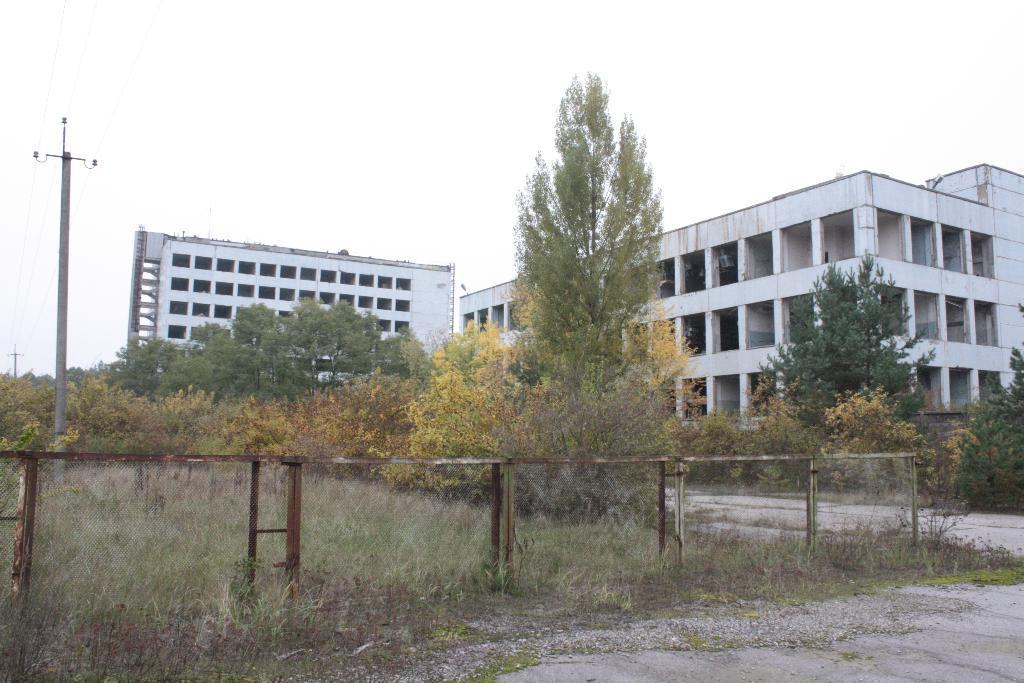Could you give a brief overview of what you see in this image? This image consists of grass, plants, fence, light poles, wires, trees, buildings, pillars and the sky. This image is taken may be during a day. 